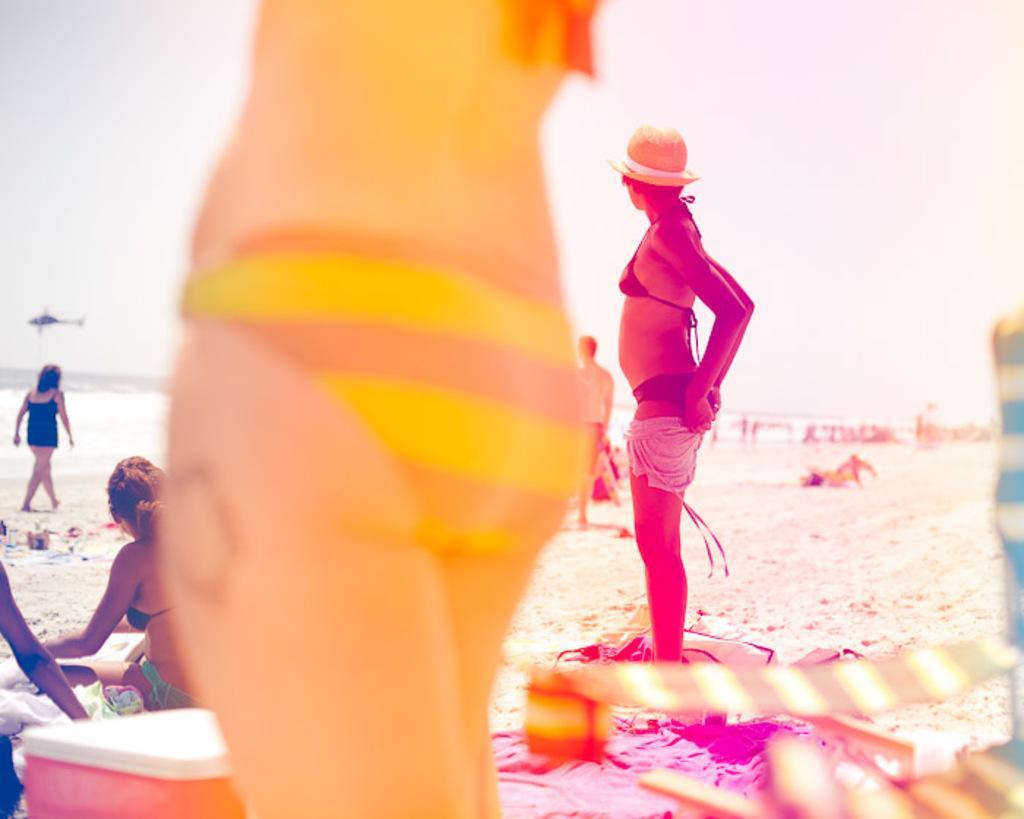Describe this image in one or two sentences. In this image there are few people on the sea shore, there is a plane over the water, chairs, a box and the sky. 